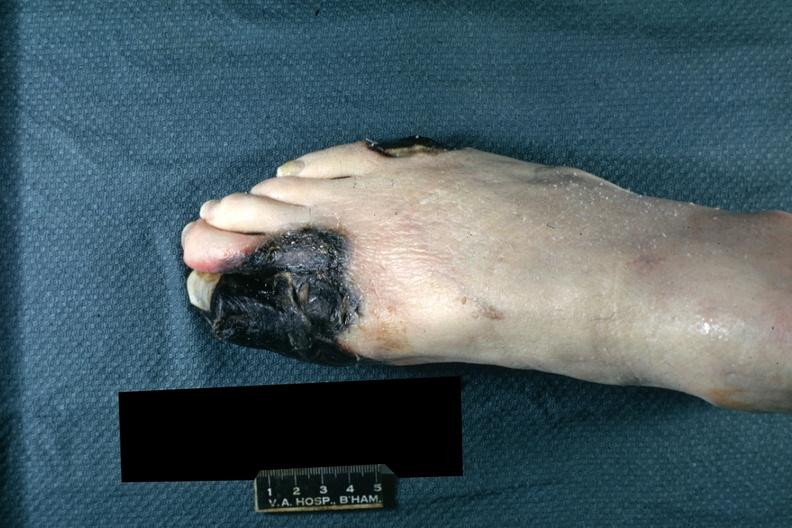does this image show well demarcated black tissue great and second toe and lateral aspect of small toe?
Answer the question using a single word or phrase. Yes 